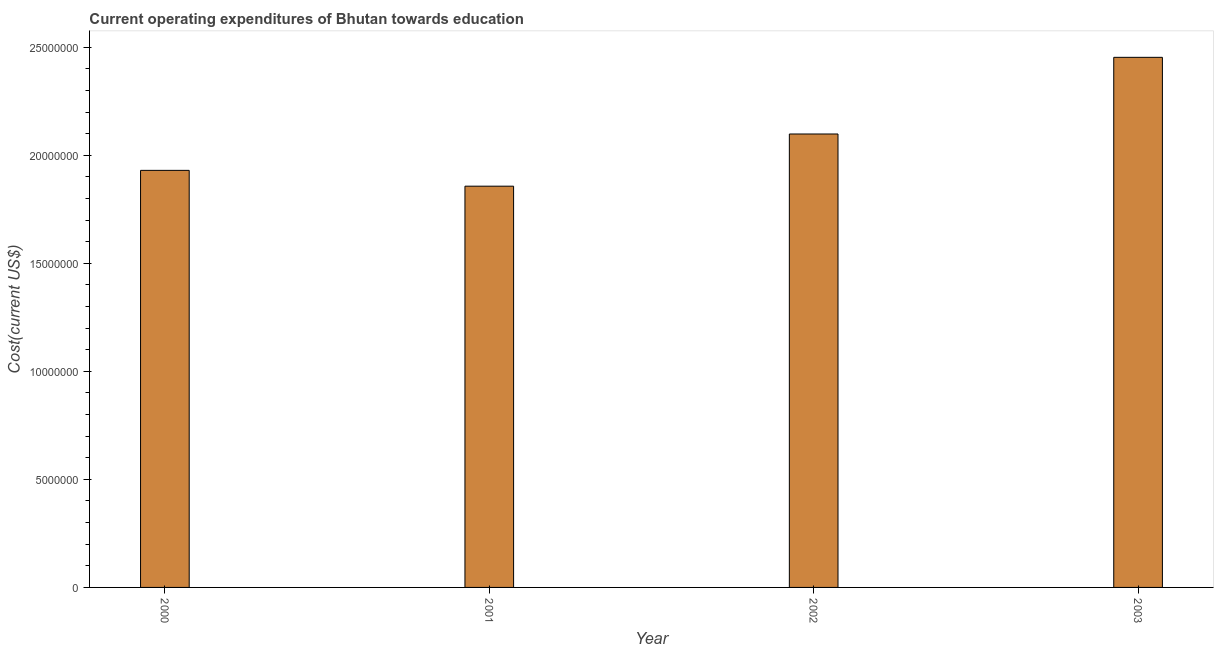Does the graph contain any zero values?
Offer a very short reply. No. Does the graph contain grids?
Offer a terse response. No. What is the title of the graph?
Your response must be concise. Current operating expenditures of Bhutan towards education. What is the label or title of the X-axis?
Provide a succinct answer. Year. What is the label or title of the Y-axis?
Your answer should be very brief. Cost(current US$). What is the education expenditure in 2001?
Offer a very short reply. 1.86e+07. Across all years, what is the maximum education expenditure?
Make the answer very short. 2.45e+07. Across all years, what is the minimum education expenditure?
Ensure brevity in your answer.  1.86e+07. What is the sum of the education expenditure?
Offer a terse response. 8.34e+07. What is the difference between the education expenditure in 2001 and 2003?
Provide a short and direct response. -5.96e+06. What is the average education expenditure per year?
Make the answer very short. 2.08e+07. What is the median education expenditure?
Your answer should be compact. 2.01e+07. In how many years, is the education expenditure greater than 10000000 US$?
Give a very brief answer. 4. What is the ratio of the education expenditure in 2001 to that in 2003?
Make the answer very short. 0.76. Is the difference between the education expenditure in 2000 and 2002 greater than the difference between any two years?
Offer a very short reply. No. What is the difference between the highest and the second highest education expenditure?
Ensure brevity in your answer.  3.55e+06. Is the sum of the education expenditure in 2000 and 2001 greater than the maximum education expenditure across all years?
Ensure brevity in your answer.  Yes. What is the difference between the highest and the lowest education expenditure?
Keep it short and to the point. 5.96e+06. Are all the bars in the graph horizontal?
Your answer should be very brief. No. What is the Cost(current US$) of 2000?
Give a very brief answer. 1.93e+07. What is the Cost(current US$) of 2001?
Make the answer very short. 1.86e+07. What is the Cost(current US$) of 2002?
Provide a short and direct response. 2.10e+07. What is the Cost(current US$) in 2003?
Make the answer very short. 2.45e+07. What is the difference between the Cost(current US$) in 2000 and 2001?
Your answer should be compact. 7.32e+05. What is the difference between the Cost(current US$) in 2000 and 2002?
Make the answer very short. -1.68e+06. What is the difference between the Cost(current US$) in 2000 and 2003?
Offer a very short reply. -5.23e+06. What is the difference between the Cost(current US$) in 2001 and 2002?
Your response must be concise. -2.42e+06. What is the difference between the Cost(current US$) in 2001 and 2003?
Offer a very short reply. -5.96e+06. What is the difference between the Cost(current US$) in 2002 and 2003?
Provide a succinct answer. -3.55e+06. What is the ratio of the Cost(current US$) in 2000 to that in 2001?
Offer a terse response. 1.04. What is the ratio of the Cost(current US$) in 2000 to that in 2002?
Provide a short and direct response. 0.92. What is the ratio of the Cost(current US$) in 2000 to that in 2003?
Your answer should be compact. 0.79. What is the ratio of the Cost(current US$) in 2001 to that in 2002?
Offer a terse response. 0.89. What is the ratio of the Cost(current US$) in 2001 to that in 2003?
Provide a short and direct response. 0.76. What is the ratio of the Cost(current US$) in 2002 to that in 2003?
Make the answer very short. 0.85. 